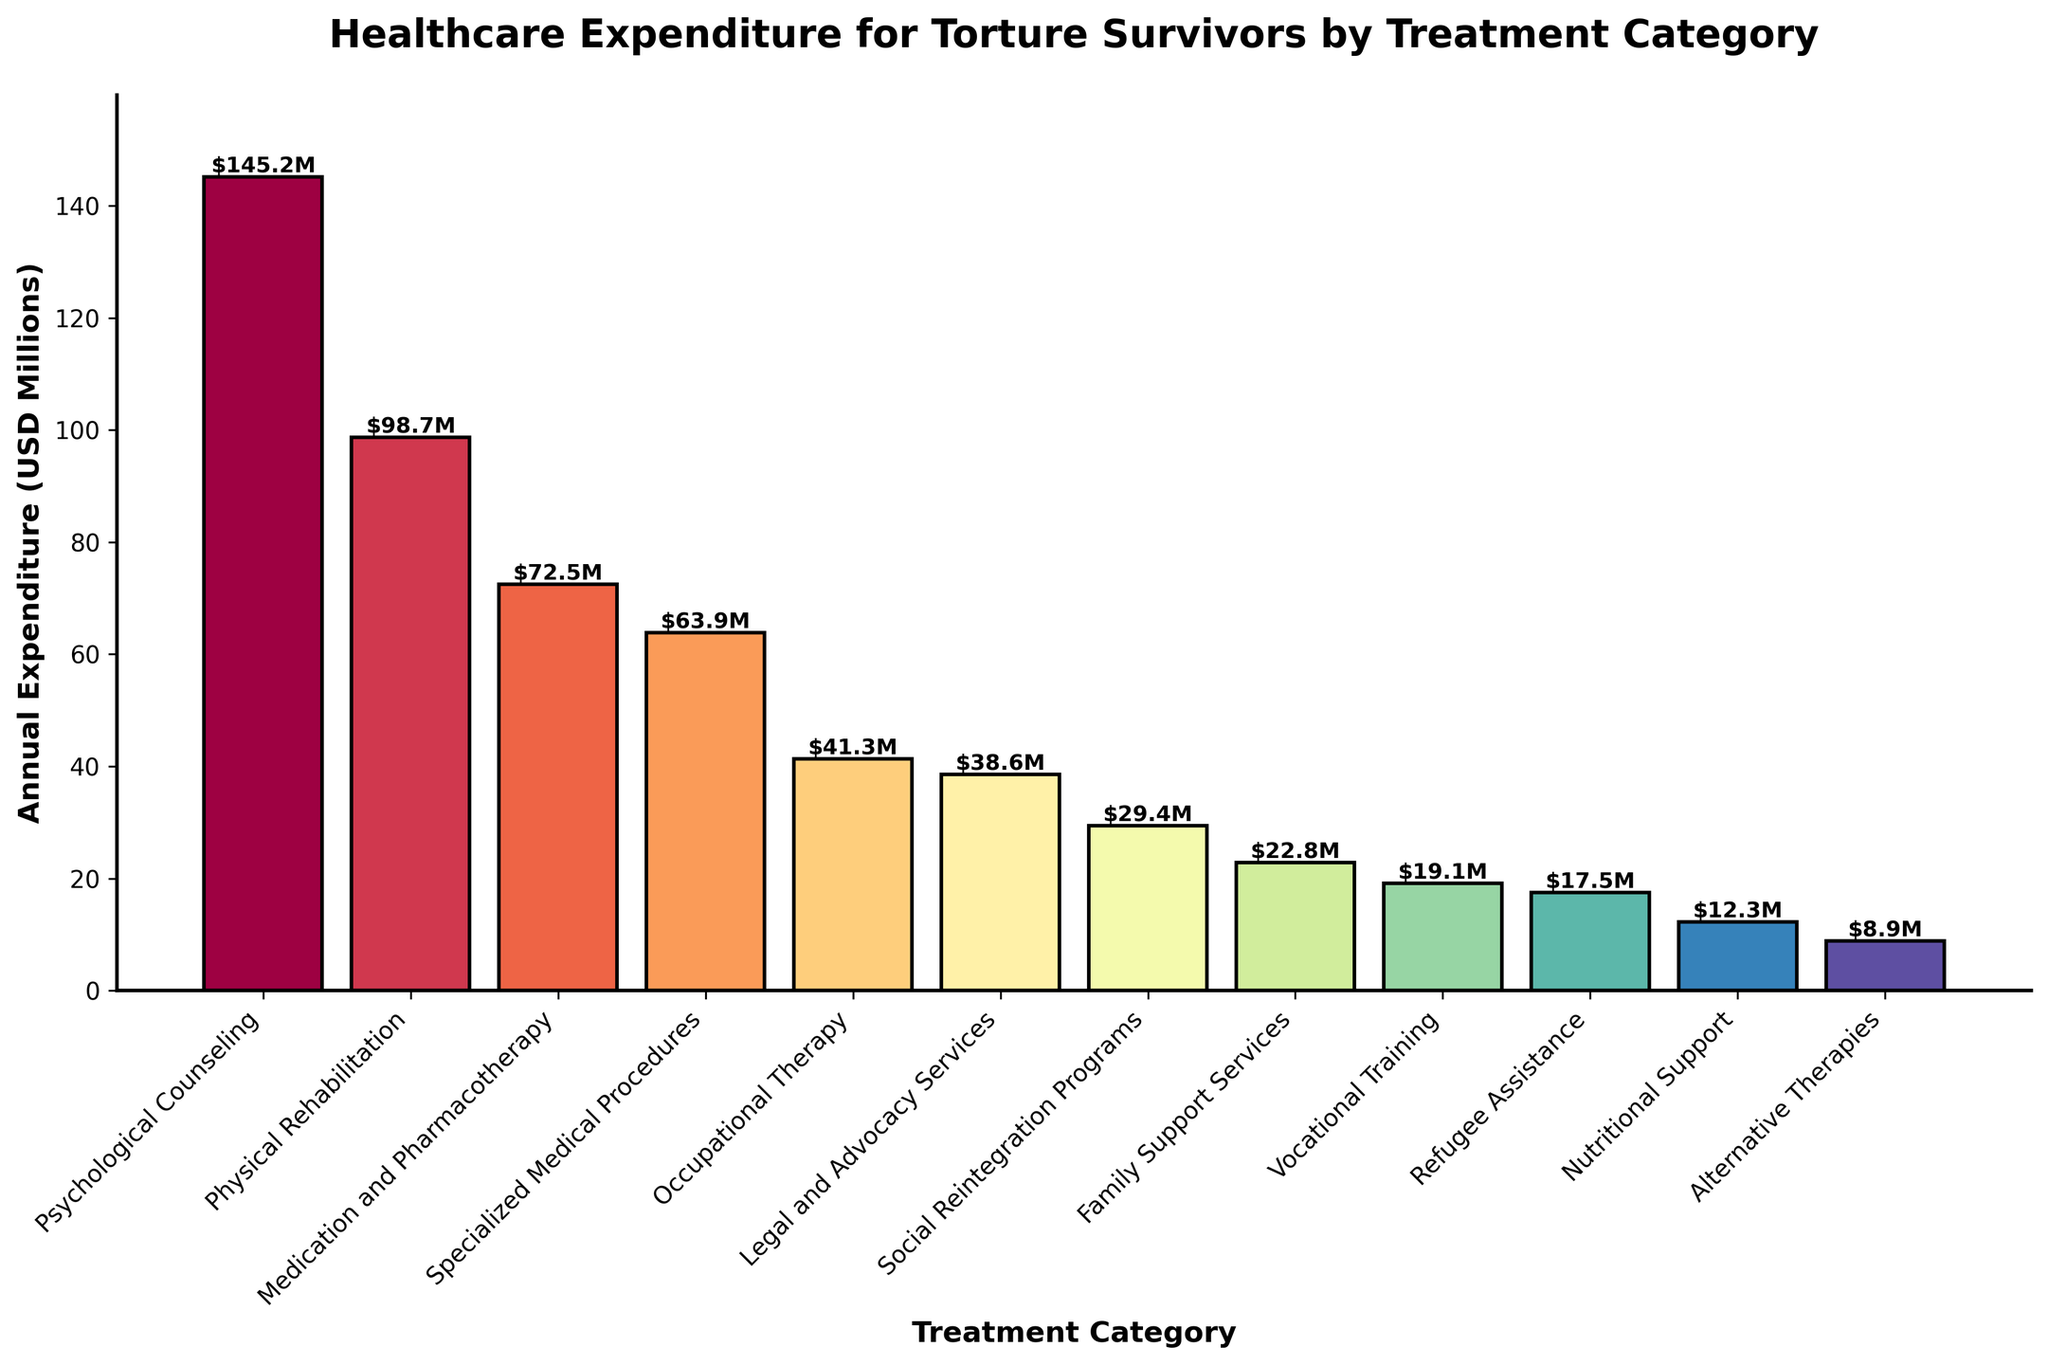What is the total expenditure for Psychological Counseling and Physical Rehabilitation combined? Add the expenditure for Psychological Counseling (145.2) and Physical Rehabilitation (98.7). 145.2 + 98.7 = 243.9
Answer: 243.9 Which treatment category has the lowest annual expenditure? Identify the category with the shortest bar on the graph and read its label. The shortest bar represents Alternative Therapies.
Answer: Alternative Therapies How much more is spent on Psychological Counseling compared to Medication and Pharmacotherapy? Subtract the expenditure for Medication and Pharmacotherapy (72.5) from the expenditure for Psychological Counseling (145.2). 145.2 - 72.5 = 72.7
Answer: 72.7 What is the average annual expenditure for Occupational Therapy, Legal and Advocacy Services, and Social Reintegration Programs? Add the expenditures and divide by the number of categories: (41.3 + 38.6 + 29.4) / 3 = 36.43.
Answer: 36.43 Which category has a higher expenditure: Family Support Services or Vocational Training? Compare the lengths of the bars for Family Support Services (22.8) and Vocational Training (19.1). Family Support Services has a higher expenditure.
Answer: Family Support Services What is the combined annual expenditure for the three categories with the highest spending? Add the expenditures for Psychological Counseling (145.2), Physical Rehabilitation (98.7), and Medication and Pharmacotherapy (72.5). 145.2 + 98.7 + 72.5 = 316.4
Answer: 316.4 Which category spends more on treatment: Nutritional Support or Refugee Assistance? Compare the lengths of the bars for Nutritional Support (12.3) and Refugee Assistance (17.5). Refugee Assistance has a higher expenditure.
Answer: Refugee Assistance What is the difference between the expenditures for Specialized Medical Procedures and Nutritional Support? Subtract the expenditure for Nutritional Support (12.3) from the expenditure for Specialized Medical Procedures (63.9). 63.9 - 12.3 = 51.6
Answer: 51.6 Which treatment category falls in the middle in terms of expenditure? Identify the median category by listing all expenditures in order and finding the middle value. The expenditures are sorted as: 8.9, 12.3, 17.5, 19.1, 22.8, 29.4, 38.6, 41.3, 63.9, 72.5, 98.7, 145.2. The middle category is Social Reintegration Programs with 29.4.
Answer: Social Reintegration Programs Which category incurs almost double the expenditure of Alternative Therapies? Identify the category closest to 2 * 8.9 = 17.8. Refugee Assistance, with 17.5, is the closest and slightly less than double.
Answer: Refugee Assistance 